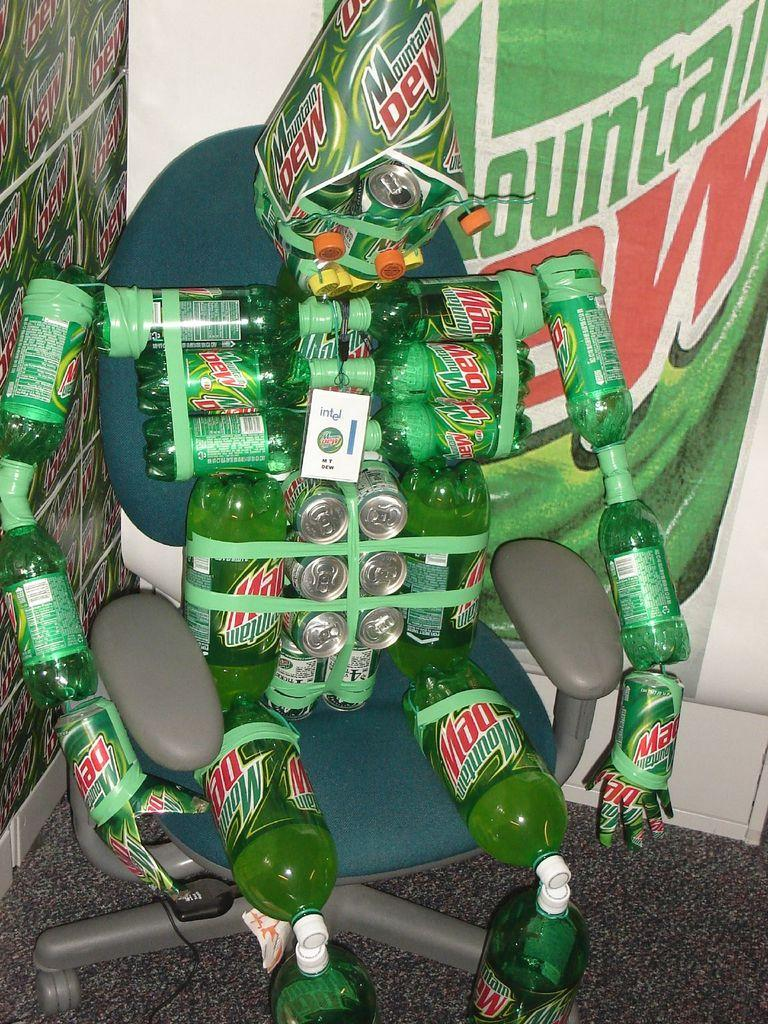<image>
Describe the image concisely. All the Mountain Dew bottles and cans have been taped together in the shape of a man and seated in an office chair. 